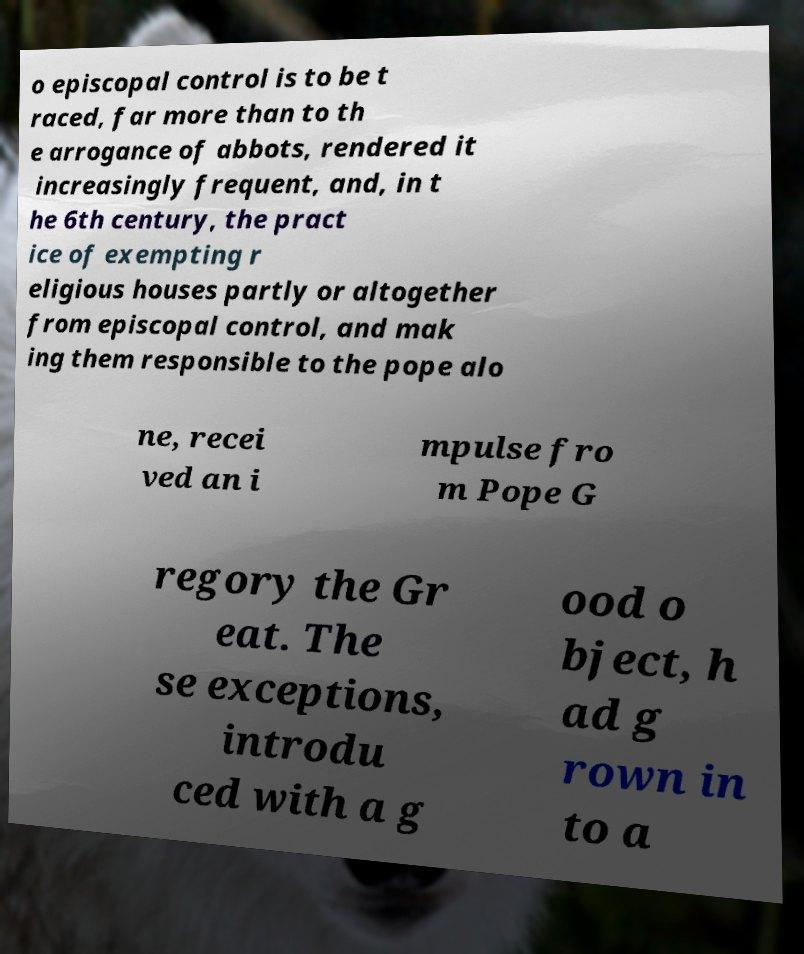I need the written content from this picture converted into text. Can you do that? o episcopal control is to be t raced, far more than to th e arrogance of abbots, rendered it increasingly frequent, and, in t he 6th century, the pract ice of exempting r eligious houses partly or altogether from episcopal control, and mak ing them responsible to the pope alo ne, recei ved an i mpulse fro m Pope G regory the Gr eat. The se exceptions, introdu ced with a g ood o bject, h ad g rown in to a 